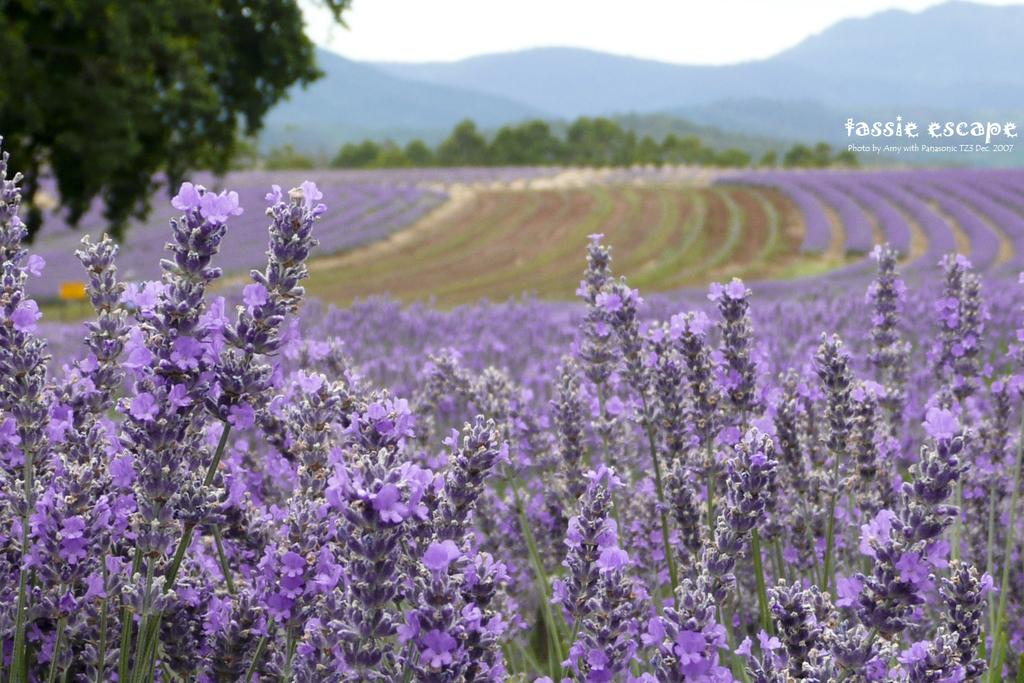What type of flora can be seen in the image? There are tiny flowers in the image. What color are the flowers? The flowers are purple in color. What other natural elements are present in the image? There are trees and mountains in the image. What part of the sky is visible in the image? The sky is visible in the image. Is there any text or marking in the image? Yes, there is a watermark in the top right corner of the image. What type of celery is being held by the wrist in the image? There is no celery or wrist present in the image. How many apples are visible on the wrist in the image? There are no apples or wrists present in the image. 